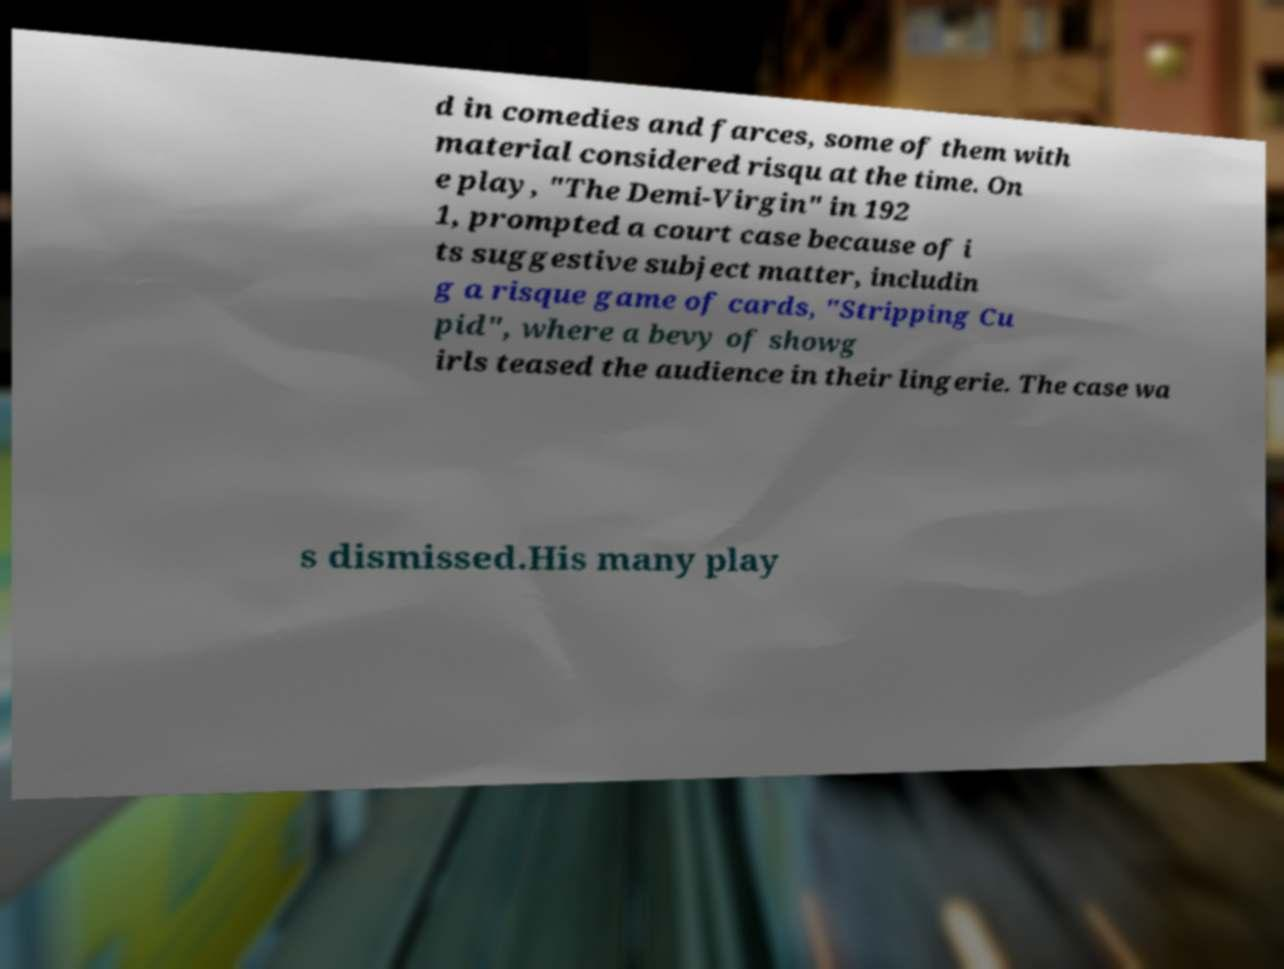Can you read and provide the text displayed in the image?This photo seems to have some interesting text. Can you extract and type it out for me? d in comedies and farces, some of them with material considered risqu at the time. On e play, "The Demi-Virgin" in 192 1, prompted a court case because of i ts suggestive subject matter, includin g a risque game of cards, "Stripping Cu pid", where a bevy of showg irls teased the audience in their lingerie. The case wa s dismissed.His many play 